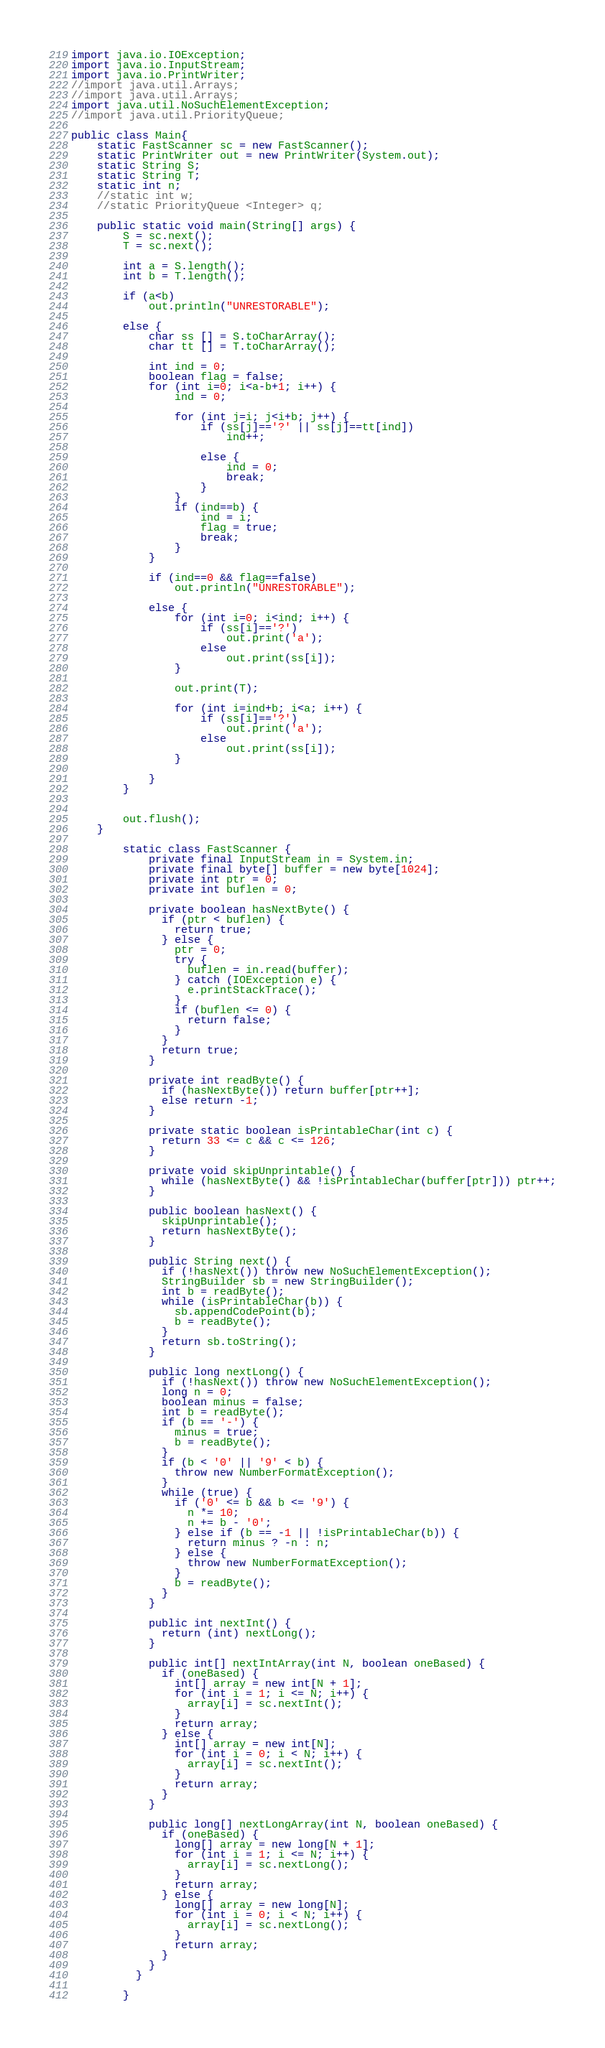Convert code to text. <code><loc_0><loc_0><loc_500><loc_500><_Java_>import java.io.IOException;
import java.io.InputStream;
import java.io.PrintWriter;
//import java.util.Arrays;
//import java.util.Arrays;
import java.util.NoSuchElementException;
//import java.util.PriorityQueue;

public class Main{
	static FastScanner sc = new FastScanner();
	static PrintWriter out = new PrintWriter(System.out);
	static String S;
	static String T;
	static int n;
	//static int w;
	//static PriorityQueue <Integer> q;
	
	public static void main(String[] args) {
		S = sc.next();
		T = sc.next();
		
		int a = S.length();
		int b = T.length();
		
		if (a<b)
			out.println("UNRESTORABLE");
		
		else {
			char ss [] = S.toCharArray();
			char tt [] = T.toCharArray();

			int ind = 0;
			boolean flag = false;
			for (int i=0; i<a-b+1; i++) {
				ind = 0;
				
				for (int j=i; j<i+b; j++) {
					if (ss[j]=='?' || ss[j]==tt[ind])
						ind++;
					
					else {
						ind = 0;
						break;
					}
				}		
				if (ind==b) {
					ind = i;
					flag = true;
					break;
				}
			}	
			
			if (ind==0 && flag==false)
				out.println("UNRESTORABLE");
			
			else {
				for (int i=0; i<ind; i++) {
					if (ss[i]=='?')
						out.print('a');
					else
						out.print(ss[i]);
				}
				
				out.print(T);
				
				for (int i=ind+b; i<a; i++) {
					if (ss[i]=='?')
						out.print('a');
					else
						out.print(ss[i]);
				}
				
			}
		}
		
		
		out.flush();
	}
	
		static class FastScanner {
		    private final InputStream in = System.in;
		    private final byte[] buffer = new byte[1024];
		    private int ptr = 0;
		    private int buflen = 0;

		    private boolean hasNextByte() {
		      if (ptr < buflen) {
		        return true;
		      } else {
		        ptr = 0;
		        try {
		          buflen = in.read(buffer);
		        } catch (IOException e) {
		          e.printStackTrace();
		        }
		        if (buflen <= 0) {
		          return false;
		        }
		      }
		      return true;
		    }

		    private int readByte() {
		      if (hasNextByte()) return buffer[ptr++];
		      else return -1;
		    }

		    private static boolean isPrintableChar(int c) {
		      return 33 <= c && c <= 126;
		    }

		    private void skipUnprintable() {
		      while (hasNextByte() && !isPrintableChar(buffer[ptr])) ptr++;
		    }

		    public boolean hasNext() {
		      skipUnprintable();
		      return hasNextByte();
		    }

		    public String next() {
		      if (!hasNext()) throw new NoSuchElementException();
		      StringBuilder sb = new StringBuilder();
		      int b = readByte();
		      while (isPrintableChar(b)) {
		        sb.appendCodePoint(b);
		        b = readByte();
		      }
		      return sb.toString();
		    }

		    public long nextLong() {
		      if (!hasNext()) throw new NoSuchElementException();
		      long n = 0;
		      boolean minus = false;
		      int b = readByte();
		      if (b == '-') {
		        minus = true;
		        b = readByte();
		      }
		      if (b < '0' || '9' < b) {
		        throw new NumberFormatException();
		      }
		      while (true) {
		        if ('0' <= b && b <= '9') {
		          n *= 10;
		          n += b - '0';
		        } else if (b == -1 || !isPrintableChar(b)) {
		          return minus ? -n : n;
		        } else {
		          throw new NumberFormatException();
		        }
		        b = readByte();
		      }
		    }

		    public int nextInt() {
		      return (int) nextLong();
		    }

		    public int[] nextIntArray(int N, boolean oneBased) {
		      if (oneBased) {
		        int[] array = new int[N + 1];
		        for (int i = 1; i <= N; i++) {
		          array[i] = sc.nextInt();
		        }
		        return array;
		      } else {
		        int[] array = new int[N];
		        for (int i = 0; i < N; i++) {
		          array[i] = sc.nextInt();
		        }
		        return array;
		      }
		    }

		    public long[] nextLongArray(int N, boolean oneBased) {
		      if (oneBased) {
		        long[] array = new long[N + 1];
		        for (int i = 1; i <= N; i++) {
		          array[i] = sc.nextLong();
		        }
		        return array;
		      } else {
		        long[] array = new long[N];
		        for (int i = 0; i < N; i++) {
		          array[i] = sc.nextLong();
		        }
		        return array;
		      }
		    }
		  }

		}	 



</code> 